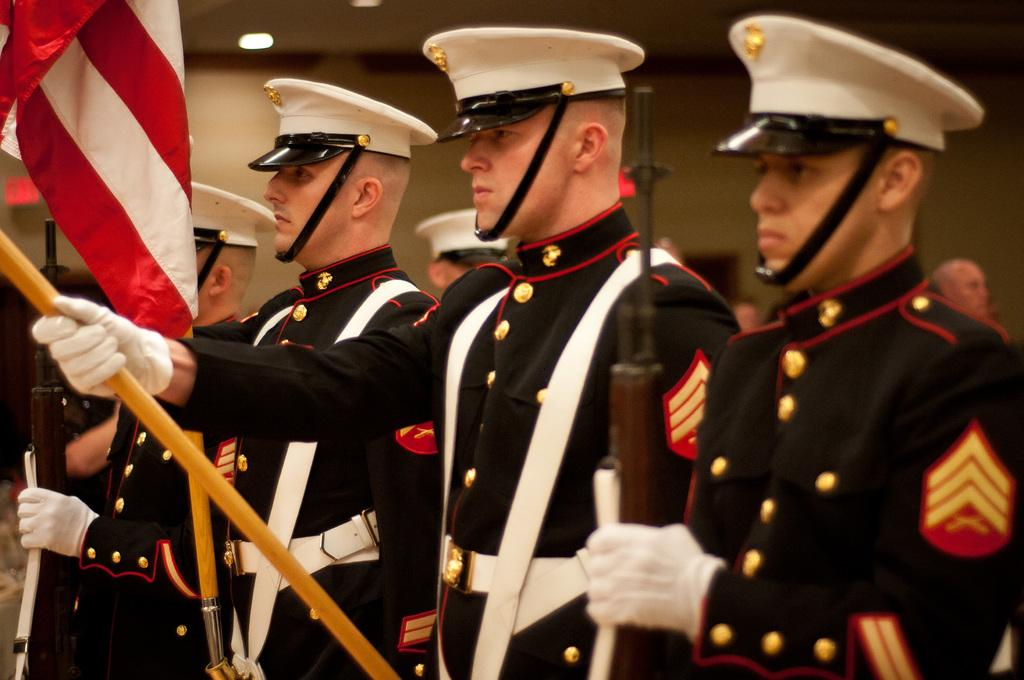How many people are in the image? There are four men in the image. What are the men wearing? The men are wearing uniforms. What is one man holding in his hand? One man is holding a gun in his hand. What is the other man holding? Another man is holding a flag. What type of industry is represented by the bee in the image? There is no bee present in the image, so it cannot be used to represent any industry. 